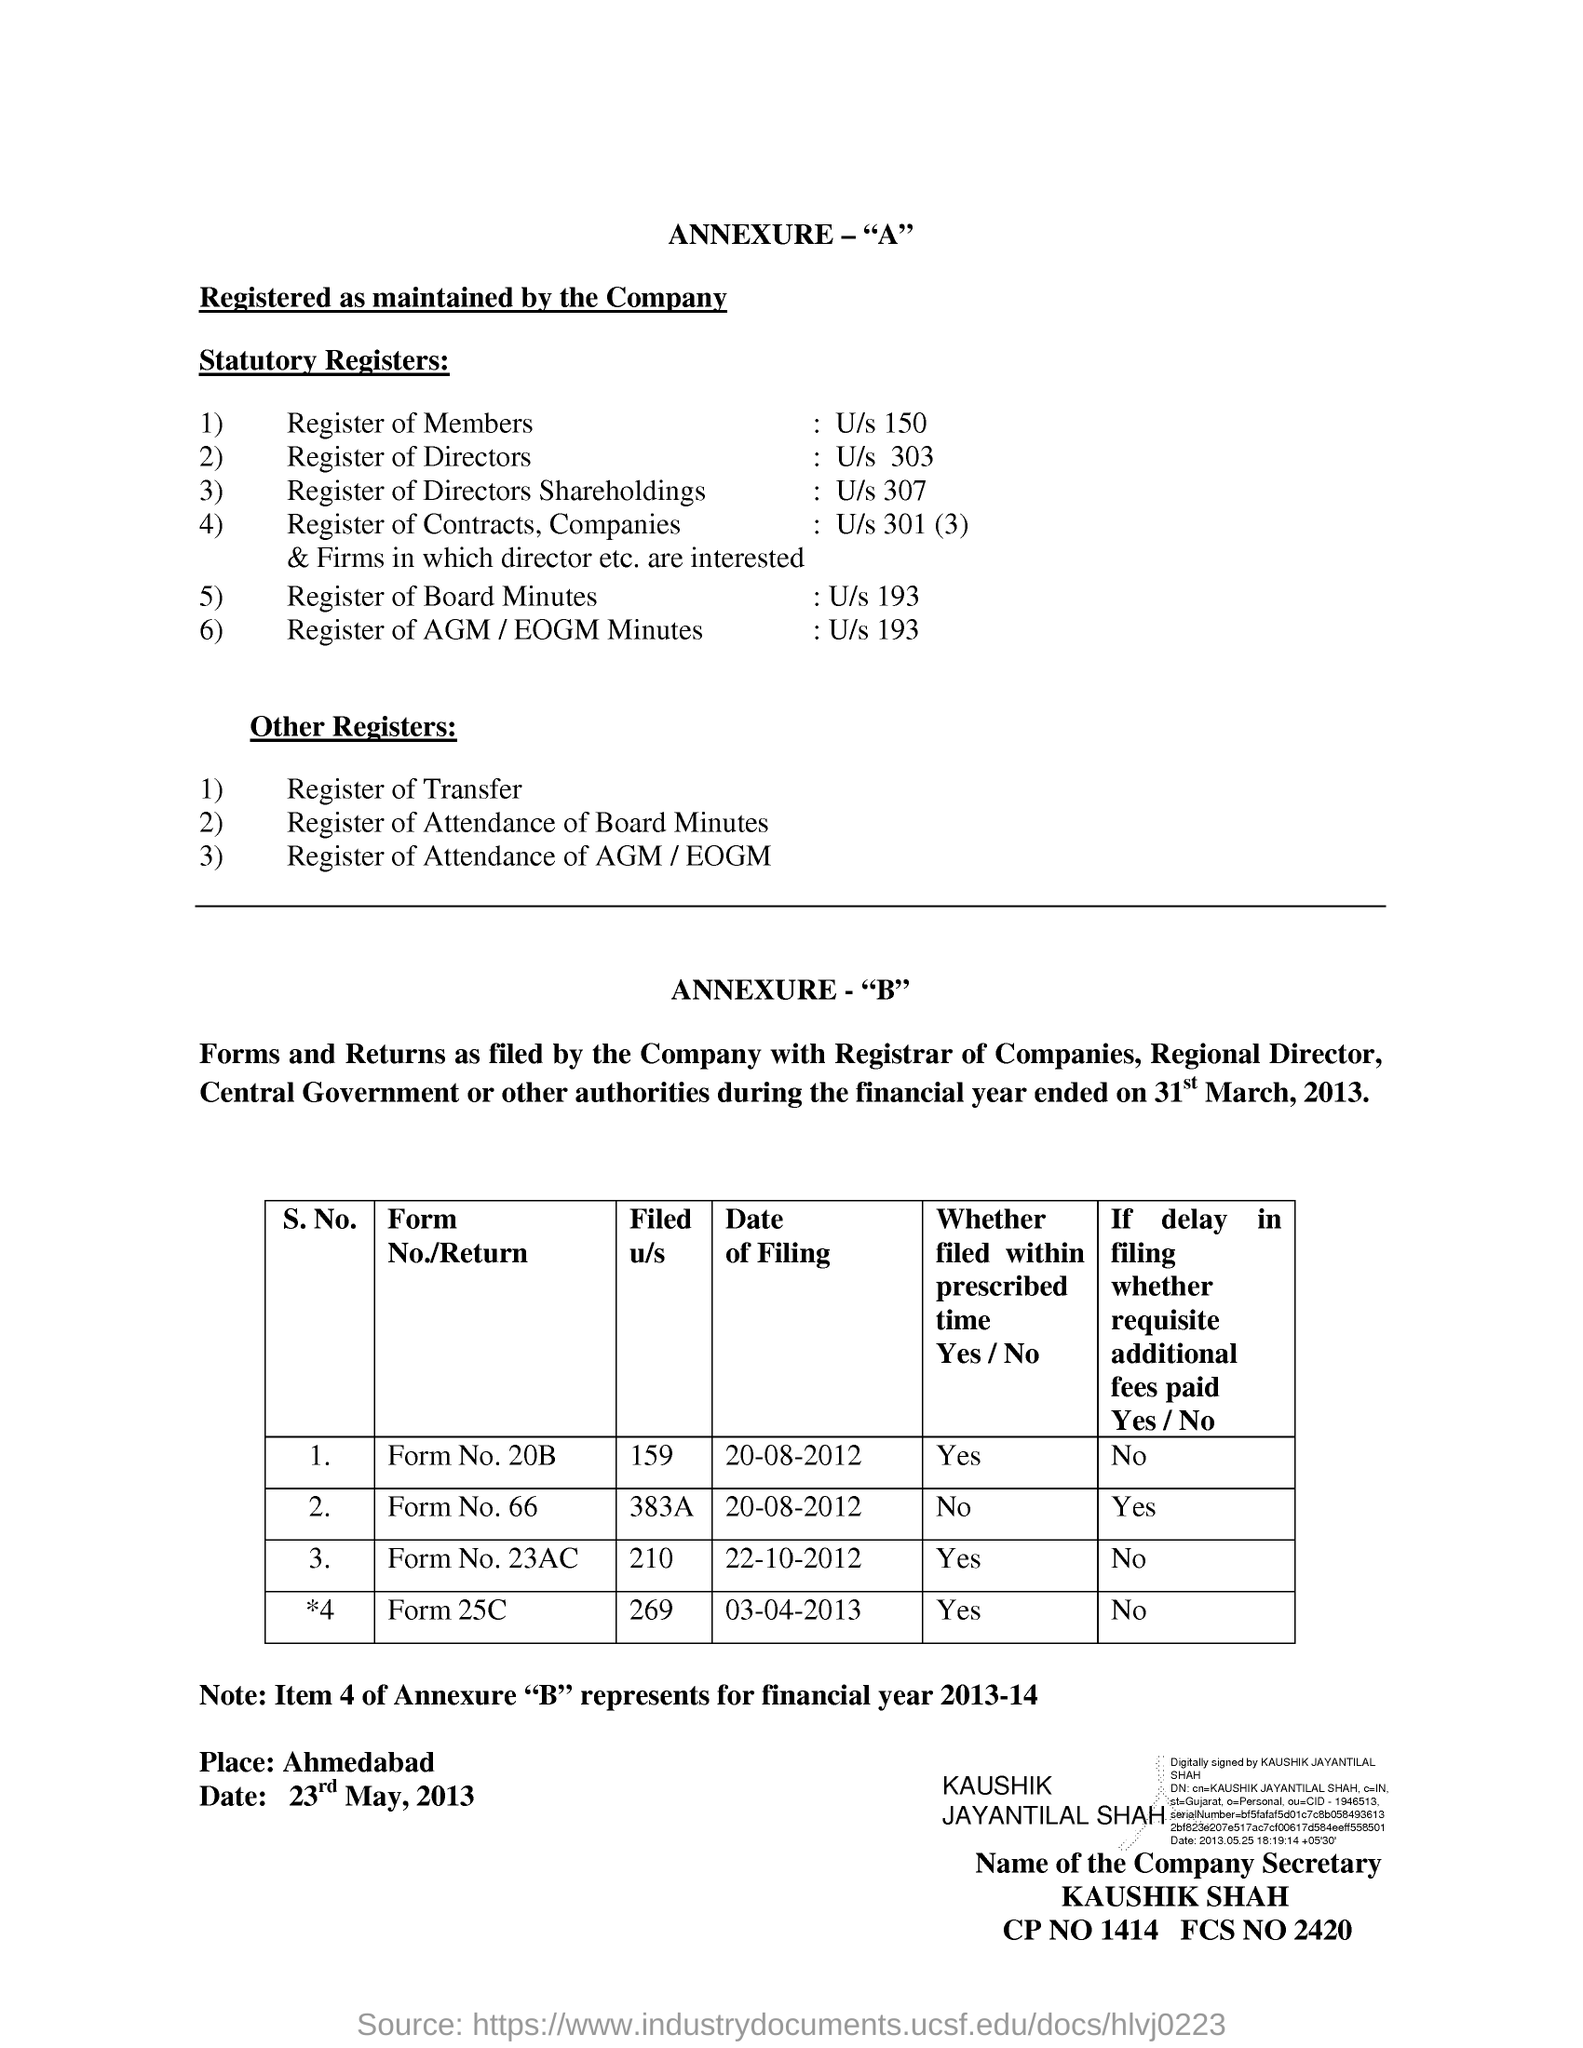How may other registers are maintained?
Your answer should be compact. 3. How many statuary registers are maintained?
Give a very brief answer. 6). 